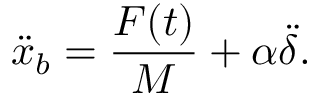Convert formula to latex. <formula><loc_0><loc_0><loc_500><loc_500>\ddot { x } _ { b } = \frac { F ( t ) } { M } + \alpha \ddot { \delta } .</formula> 